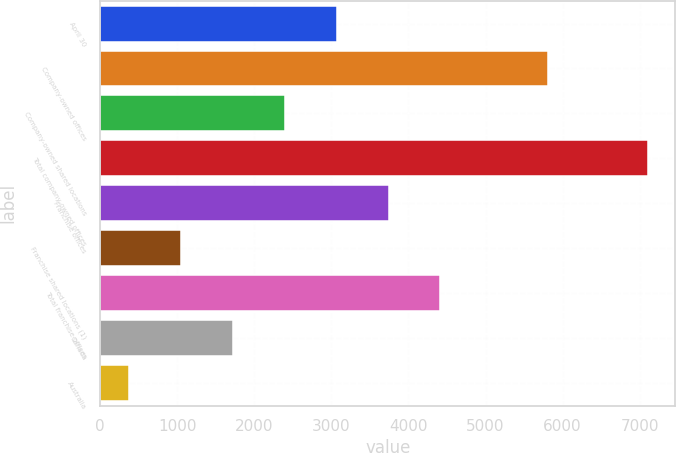<chart> <loc_0><loc_0><loc_500><loc_500><bar_chart><fcel>April 30<fcel>Company-owned offices<fcel>Company-owned shared locations<fcel>Total company-owned offices<fcel>Franchise offices<fcel>Franchise shared locations (1)<fcel>Total franchise offices<fcel>Canada<fcel>Australia<nl><fcel>3069.6<fcel>5811<fcel>2396.7<fcel>7107<fcel>3742.5<fcel>1050.9<fcel>4415.4<fcel>1723.8<fcel>378<nl></chart> 